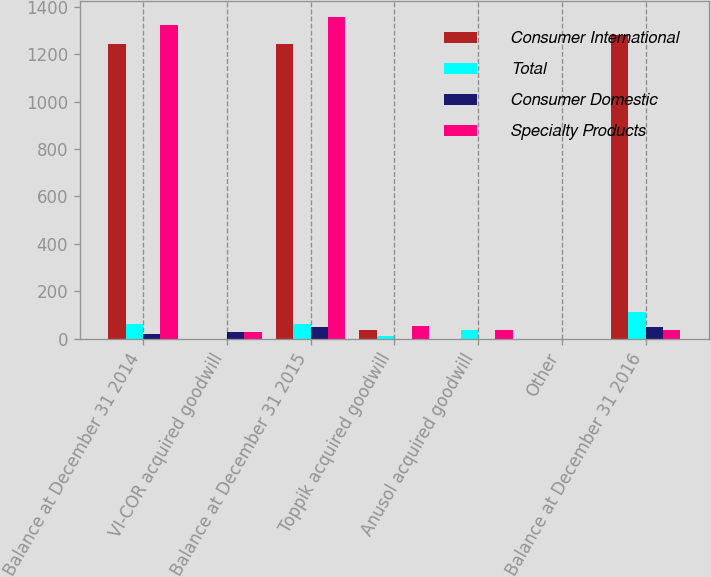Convert chart to OTSL. <chart><loc_0><loc_0><loc_500><loc_500><stacked_bar_chart><ecel><fcel>Balance at December 31 2014<fcel>VI-COR acquired goodwill<fcel>Balance at December 31 2015<fcel>Toppik acquired goodwill<fcel>Anusol acquired goodwill<fcel>Other<fcel>Balance at December 31 2016<nl><fcel>Consumer International<fcel>1242.2<fcel>0<fcel>1242.2<fcel>38.7<fcel>0<fcel>0.8<fcel>1280.1<nl><fcel>Total<fcel>62.6<fcel>0<fcel>62.6<fcel>13.6<fcel>37.8<fcel>0.1<fcel>113.9<nl><fcel>Consumer Domestic<fcel>20.2<fcel>29.9<fcel>50.1<fcel>0<fcel>0<fcel>0<fcel>50.1<nl><fcel>Specialty Products<fcel>1325<fcel>29.9<fcel>1354.9<fcel>52.3<fcel>37.8<fcel>0.9<fcel>37.8<nl></chart> 